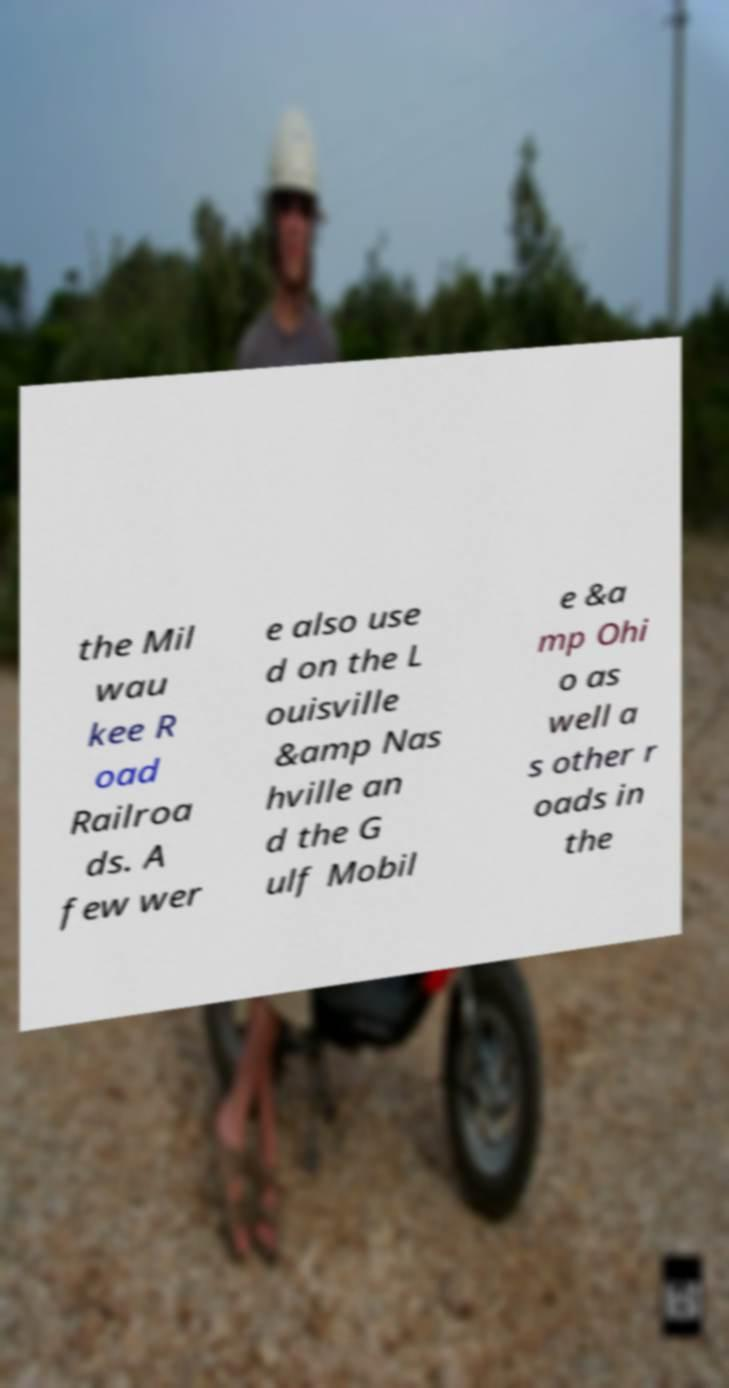For documentation purposes, I need the text within this image transcribed. Could you provide that? the Mil wau kee R oad Railroa ds. A few wer e also use d on the L ouisville &amp Nas hville an d the G ulf Mobil e &a mp Ohi o as well a s other r oads in the 